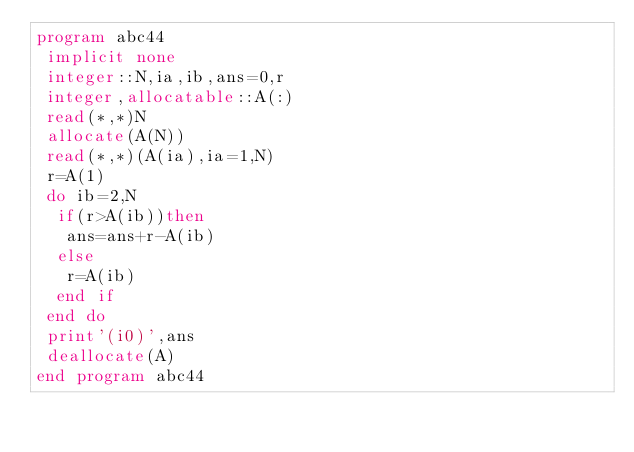<code> <loc_0><loc_0><loc_500><loc_500><_FORTRAN_>program abc44
 implicit none
 integer::N,ia,ib,ans=0,r
 integer,allocatable::A(:)
 read(*,*)N
 allocate(A(N))
 read(*,*)(A(ia),ia=1,N)
 r=A(1)
 do ib=2,N
  if(r>A(ib))then
   ans=ans+r-A(ib)
  else
   r=A(ib)
  end if
 end do
 print'(i0)',ans
 deallocate(A)
end program abc44</code> 